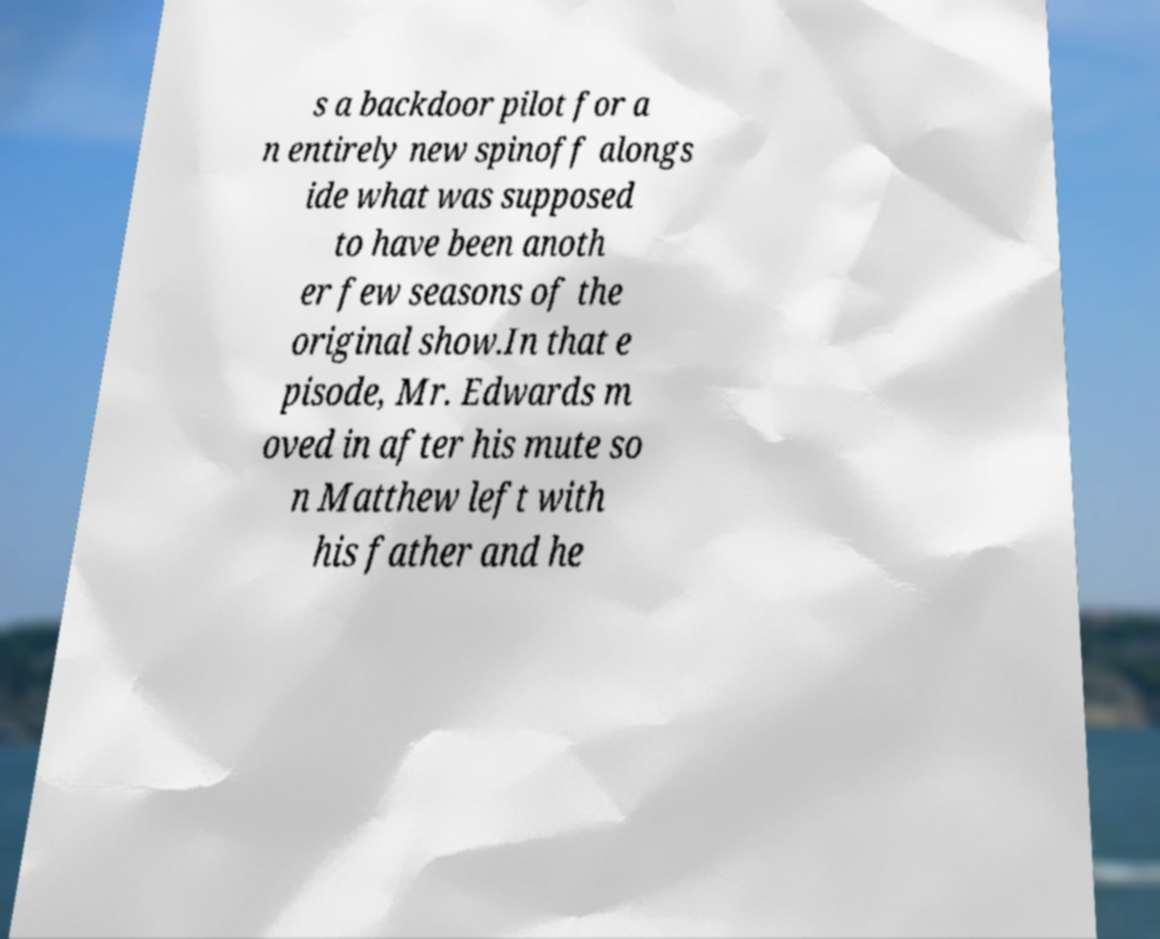What messages or text are displayed in this image? I need them in a readable, typed format. s a backdoor pilot for a n entirely new spinoff alongs ide what was supposed to have been anoth er few seasons of the original show.In that e pisode, Mr. Edwards m oved in after his mute so n Matthew left with his father and he 